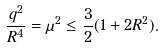<formula> <loc_0><loc_0><loc_500><loc_500>\frac { q ^ { 2 } } { R ^ { 4 } } = \mu ^ { 2 } \leq \frac { 3 } { 2 } ( 1 + 2 R ^ { 2 } ) .</formula> 